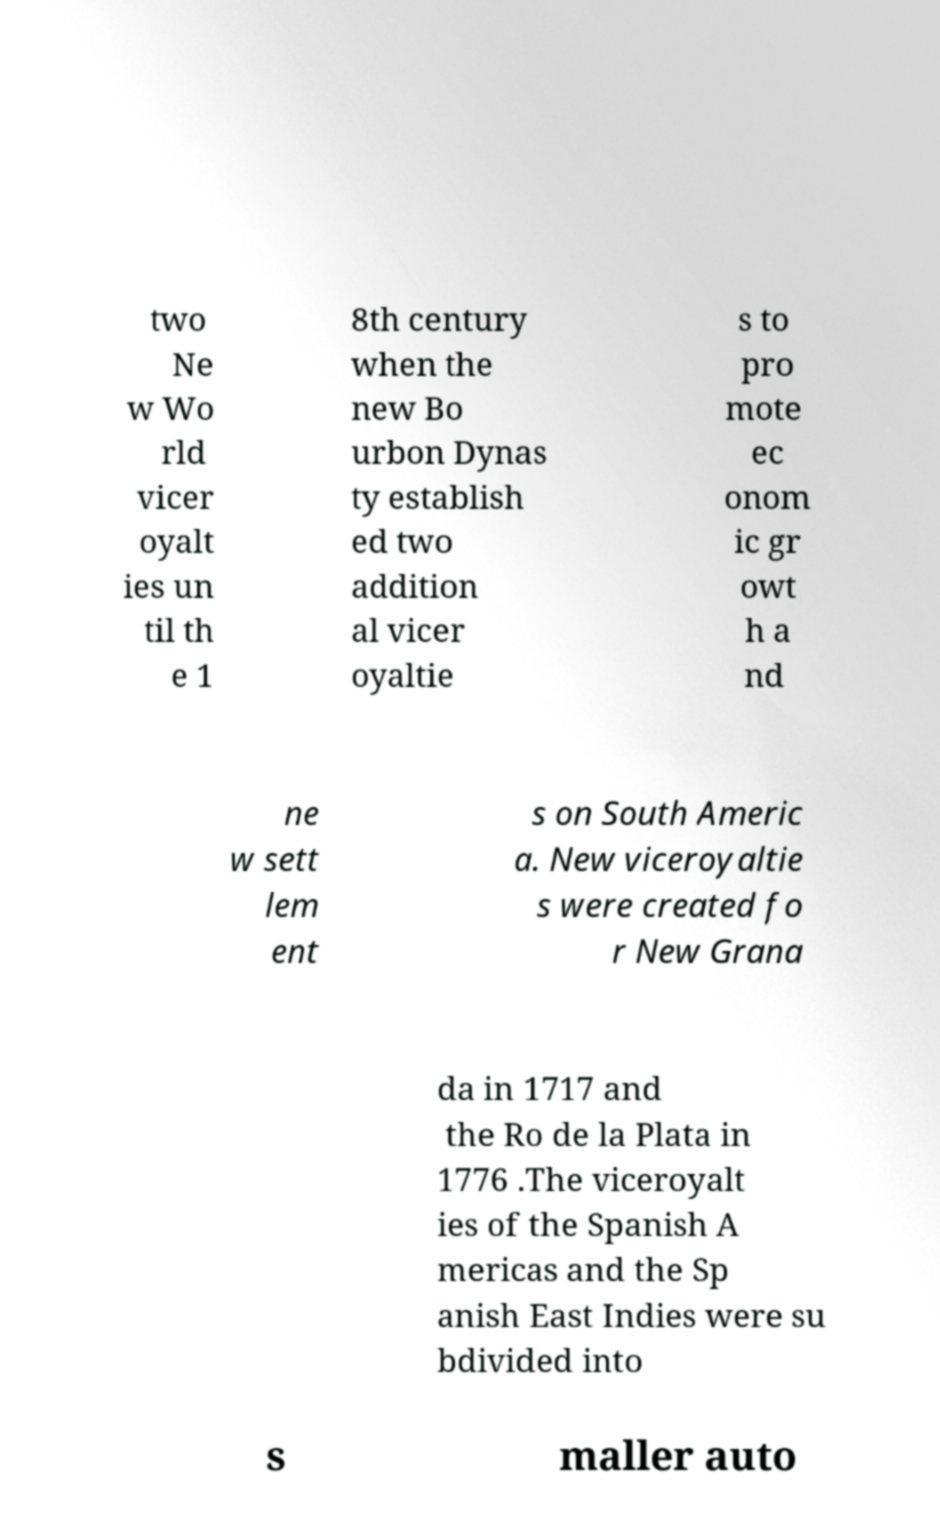I need the written content from this picture converted into text. Can you do that? two Ne w Wo rld vicer oyalt ies un til th e 1 8th century when the new Bo urbon Dynas ty establish ed two addition al vicer oyaltie s to pro mote ec onom ic gr owt h a nd ne w sett lem ent s on South Americ a. New viceroyaltie s were created fo r New Grana da in 1717 and the Ro de la Plata in 1776 .The viceroyalt ies of the Spanish A mericas and the Sp anish East Indies were su bdivided into s maller auto 